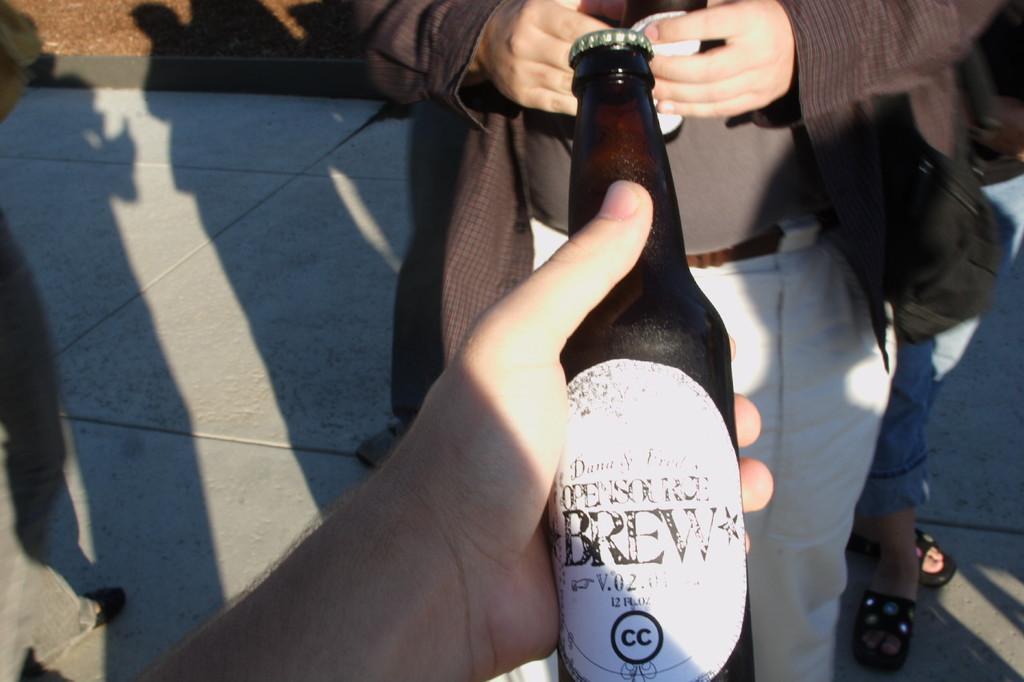Can you describe this image briefly? In this image i can see two persons and a glass bottle in a hand. 